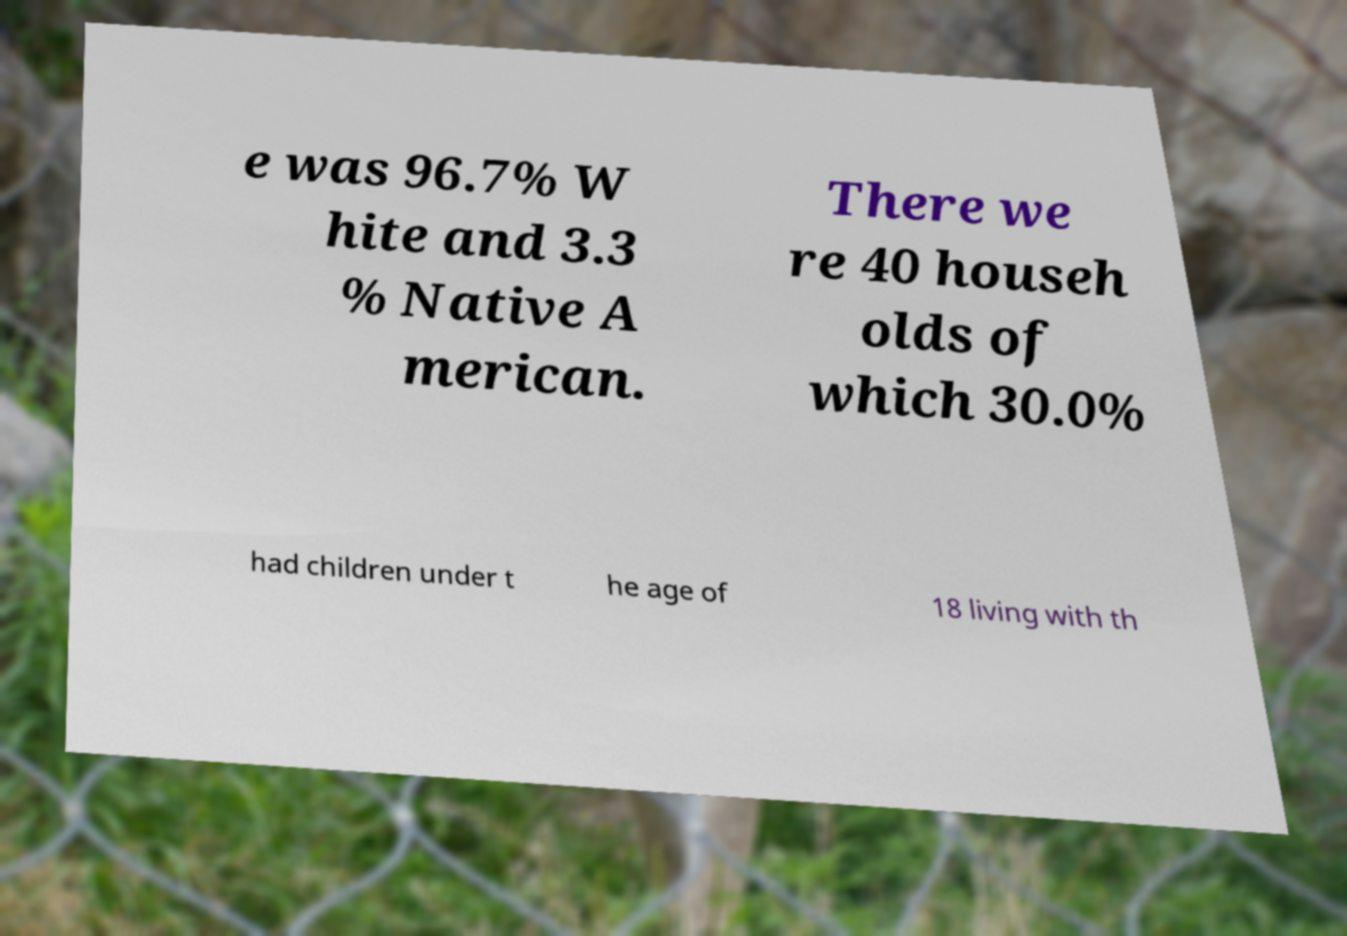Could you extract and type out the text from this image? e was 96.7% W hite and 3.3 % Native A merican. There we re 40 househ olds of which 30.0% had children under t he age of 18 living with th 